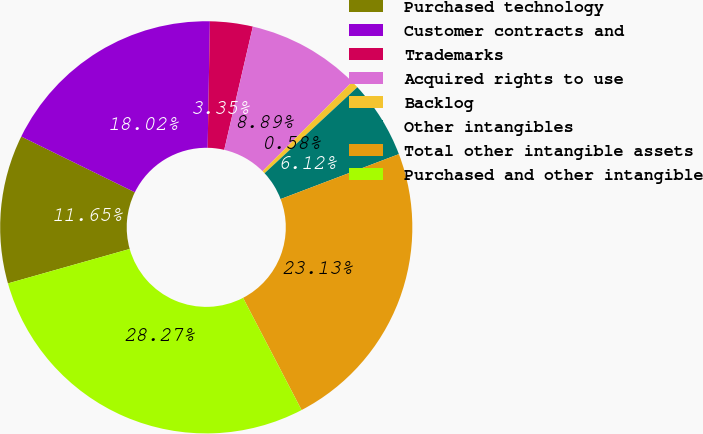Convert chart to OTSL. <chart><loc_0><loc_0><loc_500><loc_500><pie_chart><fcel>Purchased technology<fcel>Customer contracts and<fcel>Trademarks<fcel>Acquired rights to use<fcel>Backlog<fcel>Other intangibles<fcel>Total other intangible assets<fcel>Purchased and other intangible<nl><fcel>11.65%<fcel>18.02%<fcel>3.35%<fcel>8.89%<fcel>0.58%<fcel>6.12%<fcel>23.13%<fcel>28.27%<nl></chart> 